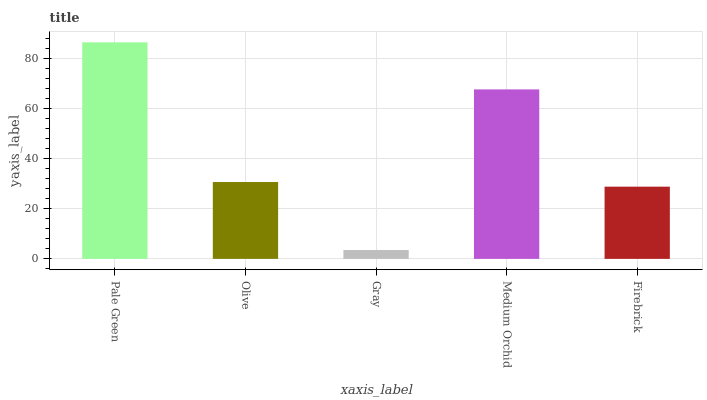Is Gray the minimum?
Answer yes or no. Yes. Is Pale Green the maximum?
Answer yes or no. Yes. Is Olive the minimum?
Answer yes or no. No. Is Olive the maximum?
Answer yes or no. No. Is Pale Green greater than Olive?
Answer yes or no. Yes. Is Olive less than Pale Green?
Answer yes or no. Yes. Is Olive greater than Pale Green?
Answer yes or no. No. Is Pale Green less than Olive?
Answer yes or no. No. Is Olive the high median?
Answer yes or no. Yes. Is Olive the low median?
Answer yes or no. Yes. Is Medium Orchid the high median?
Answer yes or no. No. Is Firebrick the low median?
Answer yes or no. No. 